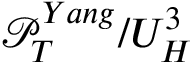<formula> <loc_0><loc_0><loc_500><loc_500>\mathcal { P } _ { T } ^ { Y a n g } / U _ { H } ^ { 3 }</formula> 